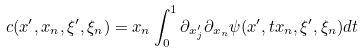<formula> <loc_0><loc_0><loc_500><loc_500>c ( x ^ { \prime } , x _ { n } , \xi ^ { \prime } , \xi _ { n } ) = x _ { n } \int _ { 0 } ^ { 1 } \partial _ { x ^ { \prime } _ { j } } \partial _ { x _ { n } } \psi ( x ^ { \prime } , t x _ { n } , \xi ^ { \prime } , \xi _ { n } ) d t</formula> 